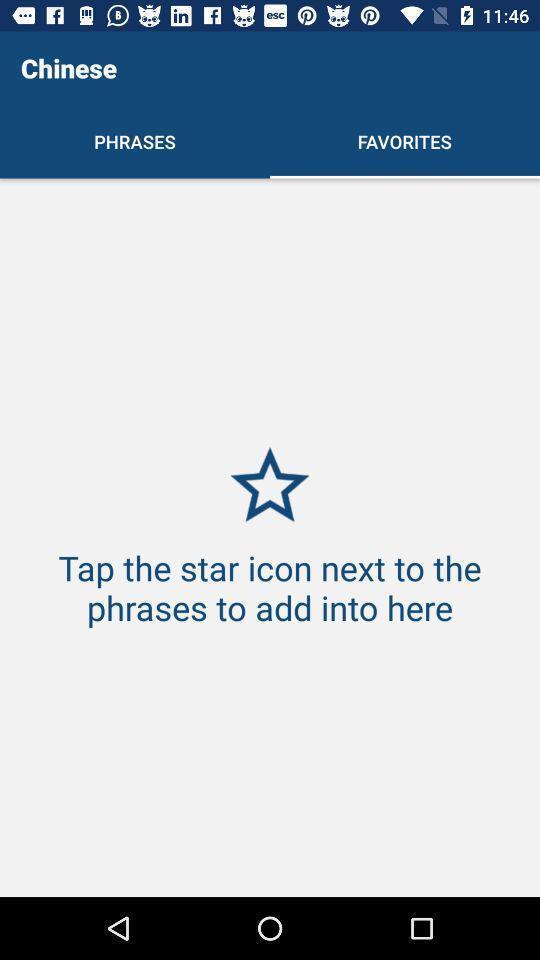What details can you identify in this image? Screen displaying page of an language learning application. 